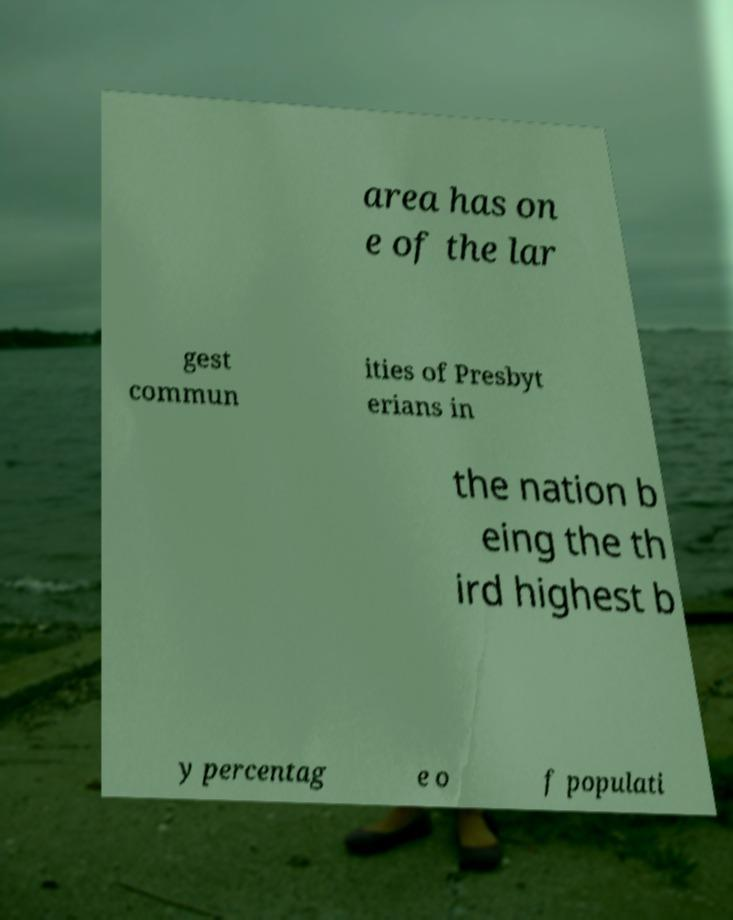Please identify and transcribe the text found in this image. area has on e of the lar gest commun ities of Presbyt erians in the nation b eing the th ird highest b y percentag e o f populati 